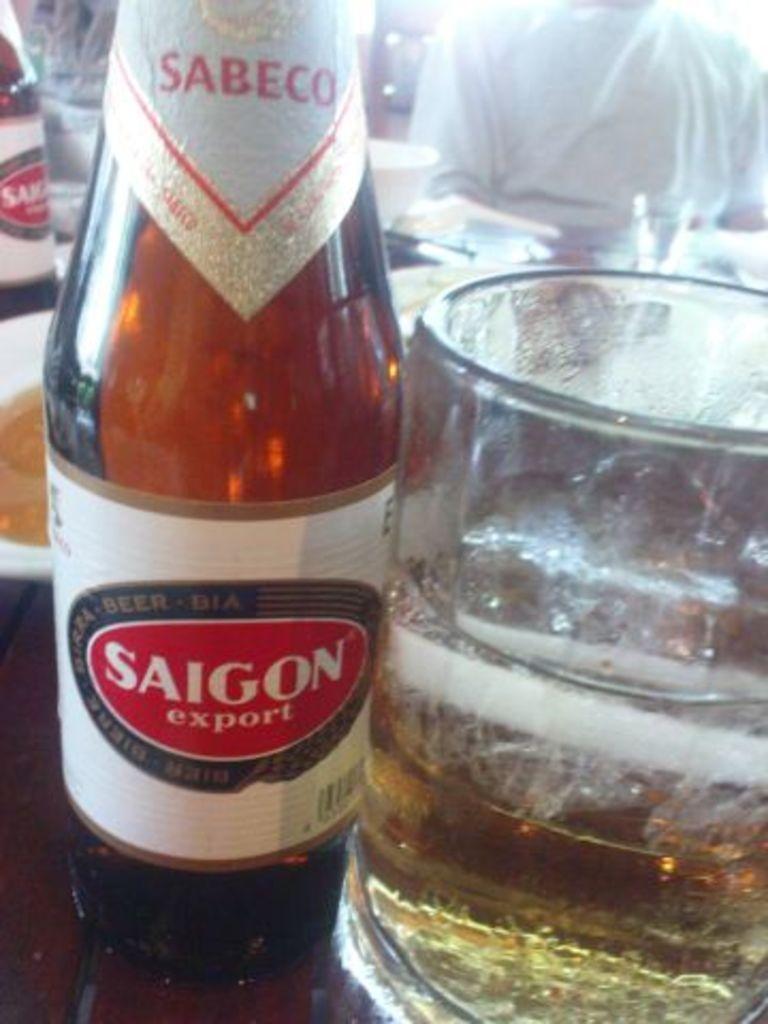What type of drink is here?
Ensure brevity in your answer.  Beer. 